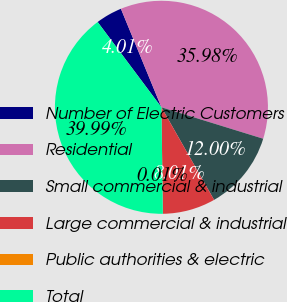<chart> <loc_0><loc_0><loc_500><loc_500><pie_chart><fcel>Number of Electric Customers<fcel>Residential<fcel>Small commercial & industrial<fcel>Large commercial & industrial<fcel>Public authorities & electric<fcel>Total<nl><fcel>4.01%<fcel>35.98%<fcel>12.0%<fcel>8.01%<fcel>0.01%<fcel>39.99%<nl></chart> 